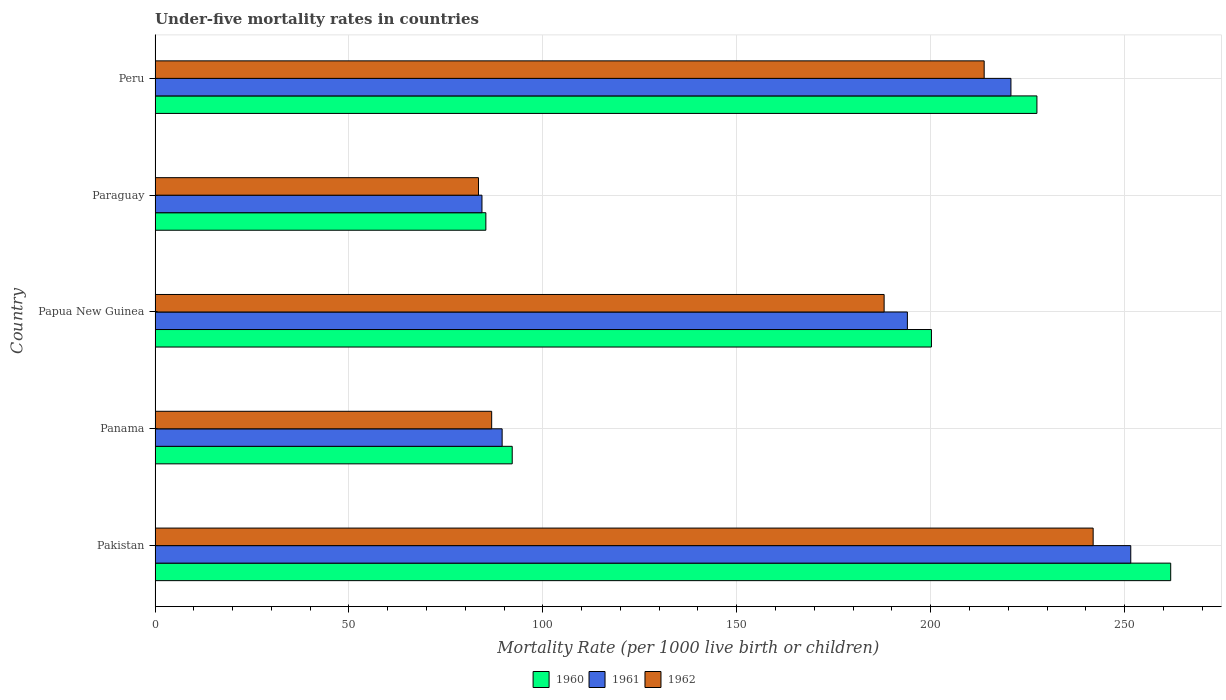How many different coloured bars are there?
Your response must be concise. 3. What is the label of the 3rd group of bars from the top?
Offer a very short reply. Papua New Guinea. What is the under-five mortality rate in 1960 in Paraguay?
Your answer should be compact. 85.3. Across all countries, what is the maximum under-five mortality rate in 1960?
Your answer should be very brief. 261.9. Across all countries, what is the minimum under-five mortality rate in 1962?
Ensure brevity in your answer.  83.4. In which country was the under-five mortality rate in 1961 maximum?
Give a very brief answer. Pakistan. In which country was the under-five mortality rate in 1961 minimum?
Make the answer very short. Paraguay. What is the total under-five mortality rate in 1962 in the graph?
Provide a short and direct response. 813.9. What is the difference between the under-five mortality rate in 1961 in Pakistan and that in Paraguay?
Offer a very short reply. 167.3. What is the difference between the under-five mortality rate in 1960 in Panama and the under-five mortality rate in 1961 in Pakistan?
Your response must be concise. -159.5. What is the average under-five mortality rate in 1960 per country?
Your answer should be very brief. 173.38. What is the difference between the under-five mortality rate in 1962 and under-five mortality rate in 1960 in Papua New Guinea?
Give a very brief answer. -12.2. What is the ratio of the under-five mortality rate in 1961 in Papua New Guinea to that in Paraguay?
Your answer should be compact. 2.3. Is the under-five mortality rate in 1960 in Pakistan less than that in Peru?
Provide a succinct answer. No. What is the difference between the highest and the second highest under-five mortality rate in 1962?
Give a very brief answer. 28.1. What is the difference between the highest and the lowest under-five mortality rate in 1960?
Your response must be concise. 176.6. Are all the bars in the graph horizontal?
Provide a succinct answer. Yes. Does the graph contain any zero values?
Offer a terse response. No. Does the graph contain grids?
Offer a very short reply. Yes. How many legend labels are there?
Offer a terse response. 3. What is the title of the graph?
Make the answer very short. Under-five mortality rates in countries. Does "1968" appear as one of the legend labels in the graph?
Offer a very short reply. No. What is the label or title of the X-axis?
Offer a very short reply. Mortality Rate (per 1000 live birth or children). What is the Mortality Rate (per 1000 live birth or children) of 1960 in Pakistan?
Your answer should be very brief. 261.9. What is the Mortality Rate (per 1000 live birth or children) in 1961 in Pakistan?
Your response must be concise. 251.6. What is the Mortality Rate (per 1000 live birth or children) of 1962 in Pakistan?
Your response must be concise. 241.9. What is the Mortality Rate (per 1000 live birth or children) in 1960 in Panama?
Offer a terse response. 92.1. What is the Mortality Rate (per 1000 live birth or children) of 1961 in Panama?
Provide a succinct answer. 89.5. What is the Mortality Rate (per 1000 live birth or children) in 1962 in Panama?
Offer a terse response. 86.8. What is the Mortality Rate (per 1000 live birth or children) of 1960 in Papua New Guinea?
Provide a succinct answer. 200.2. What is the Mortality Rate (per 1000 live birth or children) in 1961 in Papua New Guinea?
Give a very brief answer. 194. What is the Mortality Rate (per 1000 live birth or children) of 1962 in Papua New Guinea?
Your answer should be compact. 188. What is the Mortality Rate (per 1000 live birth or children) in 1960 in Paraguay?
Make the answer very short. 85.3. What is the Mortality Rate (per 1000 live birth or children) of 1961 in Paraguay?
Ensure brevity in your answer.  84.3. What is the Mortality Rate (per 1000 live birth or children) of 1962 in Paraguay?
Offer a terse response. 83.4. What is the Mortality Rate (per 1000 live birth or children) of 1960 in Peru?
Your response must be concise. 227.4. What is the Mortality Rate (per 1000 live birth or children) in 1961 in Peru?
Offer a very short reply. 220.7. What is the Mortality Rate (per 1000 live birth or children) in 1962 in Peru?
Your response must be concise. 213.8. Across all countries, what is the maximum Mortality Rate (per 1000 live birth or children) of 1960?
Your answer should be compact. 261.9. Across all countries, what is the maximum Mortality Rate (per 1000 live birth or children) in 1961?
Provide a short and direct response. 251.6. Across all countries, what is the maximum Mortality Rate (per 1000 live birth or children) in 1962?
Provide a succinct answer. 241.9. Across all countries, what is the minimum Mortality Rate (per 1000 live birth or children) in 1960?
Give a very brief answer. 85.3. Across all countries, what is the minimum Mortality Rate (per 1000 live birth or children) of 1961?
Ensure brevity in your answer.  84.3. Across all countries, what is the minimum Mortality Rate (per 1000 live birth or children) in 1962?
Your response must be concise. 83.4. What is the total Mortality Rate (per 1000 live birth or children) in 1960 in the graph?
Offer a very short reply. 866.9. What is the total Mortality Rate (per 1000 live birth or children) of 1961 in the graph?
Keep it short and to the point. 840.1. What is the total Mortality Rate (per 1000 live birth or children) in 1962 in the graph?
Offer a very short reply. 813.9. What is the difference between the Mortality Rate (per 1000 live birth or children) in 1960 in Pakistan and that in Panama?
Provide a short and direct response. 169.8. What is the difference between the Mortality Rate (per 1000 live birth or children) in 1961 in Pakistan and that in Panama?
Offer a very short reply. 162.1. What is the difference between the Mortality Rate (per 1000 live birth or children) of 1962 in Pakistan and that in Panama?
Make the answer very short. 155.1. What is the difference between the Mortality Rate (per 1000 live birth or children) in 1960 in Pakistan and that in Papua New Guinea?
Offer a very short reply. 61.7. What is the difference between the Mortality Rate (per 1000 live birth or children) of 1961 in Pakistan and that in Papua New Guinea?
Ensure brevity in your answer.  57.6. What is the difference between the Mortality Rate (per 1000 live birth or children) of 1962 in Pakistan and that in Papua New Guinea?
Provide a short and direct response. 53.9. What is the difference between the Mortality Rate (per 1000 live birth or children) of 1960 in Pakistan and that in Paraguay?
Make the answer very short. 176.6. What is the difference between the Mortality Rate (per 1000 live birth or children) of 1961 in Pakistan and that in Paraguay?
Provide a succinct answer. 167.3. What is the difference between the Mortality Rate (per 1000 live birth or children) of 1962 in Pakistan and that in Paraguay?
Your answer should be compact. 158.5. What is the difference between the Mortality Rate (per 1000 live birth or children) in 1960 in Pakistan and that in Peru?
Your answer should be compact. 34.5. What is the difference between the Mortality Rate (per 1000 live birth or children) in 1961 in Pakistan and that in Peru?
Make the answer very short. 30.9. What is the difference between the Mortality Rate (per 1000 live birth or children) of 1962 in Pakistan and that in Peru?
Provide a succinct answer. 28.1. What is the difference between the Mortality Rate (per 1000 live birth or children) in 1960 in Panama and that in Papua New Guinea?
Provide a short and direct response. -108.1. What is the difference between the Mortality Rate (per 1000 live birth or children) in 1961 in Panama and that in Papua New Guinea?
Give a very brief answer. -104.5. What is the difference between the Mortality Rate (per 1000 live birth or children) of 1962 in Panama and that in Papua New Guinea?
Keep it short and to the point. -101.2. What is the difference between the Mortality Rate (per 1000 live birth or children) of 1961 in Panama and that in Paraguay?
Your answer should be very brief. 5.2. What is the difference between the Mortality Rate (per 1000 live birth or children) of 1962 in Panama and that in Paraguay?
Your response must be concise. 3.4. What is the difference between the Mortality Rate (per 1000 live birth or children) of 1960 in Panama and that in Peru?
Keep it short and to the point. -135.3. What is the difference between the Mortality Rate (per 1000 live birth or children) of 1961 in Panama and that in Peru?
Offer a very short reply. -131.2. What is the difference between the Mortality Rate (per 1000 live birth or children) in 1962 in Panama and that in Peru?
Ensure brevity in your answer.  -127. What is the difference between the Mortality Rate (per 1000 live birth or children) in 1960 in Papua New Guinea and that in Paraguay?
Ensure brevity in your answer.  114.9. What is the difference between the Mortality Rate (per 1000 live birth or children) of 1961 in Papua New Guinea and that in Paraguay?
Make the answer very short. 109.7. What is the difference between the Mortality Rate (per 1000 live birth or children) in 1962 in Papua New Guinea and that in Paraguay?
Offer a very short reply. 104.6. What is the difference between the Mortality Rate (per 1000 live birth or children) of 1960 in Papua New Guinea and that in Peru?
Ensure brevity in your answer.  -27.2. What is the difference between the Mortality Rate (per 1000 live birth or children) of 1961 in Papua New Guinea and that in Peru?
Your answer should be very brief. -26.7. What is the difference between the Mortality Rate (per 1000 live birth or children) in 1962 in Papua New Guinea and that in Peru?
Offer a terse response. -25.8. What is the difference between the Mortality Rate (per 1000 live birth or children) in 1960 in Paraguay and that in Peru?
Your answer should be compact. -142.1. What is the difference between the Mortality Rate (per 1000 live birth or children) in 1961 in Paraguay and that in Peru?
Your answer should be compact. -136.4. What is the difference between the Mortality Rate (per 1000 live birth or children) of 1962 in Paraguay and that in Peru?
Keep it short and to the point. -130.4. What is the difference between the Mortality Rate (per 1000 live birth or children) of 1960 in Pakistan and the Mortality Rate (per 1000 live birth or children) of 1961 in Panama?
Offer a very short reply. 172.4. What is the difference between the Mortality Rate (per 1000 live birth or children) of 1960 in Pakistan and the Mortality Rate (per 1000 live birth or children) of 1962 in Panama?
Provide a succinct answer. 175.1. What is the difference between the Mortality Rate (per 1000 live birth or children) in 1961 in Pakistan and the Mortality Rate (per 1000 live birth or children) in 1962 in Panama?
Offer a very short reply. 164.8. What is the difference between the Mortality Rate (per 1000 live birth or children) in 1960 in Pakistan and the Mortality Rate (per 1000 live birth or children) in 1961 in Papua New Guinea?
Provide a succinct answer. 67.9. What is the difference between the Mortality Rate (per 1000 live birth or children) in 1960 in Pakistan and the Mortality Rate (per 1000 live birth or children) in 1962 in Papua New Guinea?
Provide a succinct answer. 73.9. What is the difference between the Mortality Rate (per 1000 live birth or children) of 1961 in Pakistan and the Mortality Rate (per 1000 live birth or children) of 1962 in Papua New Guinea?
Your answer should be very brief. 63.6. What is the difference between the Mortality Rate (per 1000 live birth or children) in 1960 in Pakistan and the Mortality Rate (per 1000 live birth or children) in 1961 in Paraguay?
Ensure brevity in your answer.  177.6. What is the difference between the Mortality Rate (per 1000 live birth or children) in 1960 in Pakistan and the Mortality Rate (per 1000 live birth or children) in 1962 in Paraguay?
Give a very brief answer. 178.5. What is the difference between the Mortality Rate (per 1000 live birth or children) in 1961 in Pakistan and the Mortality Rate (per 1000 live birth or children) in 1962 in Paraguay?
Give a very brief answer. 168.2. What is the difference between the Mortality Rate (per 1000 live birth or children) of 1960 in Pakistan and the Mortality Rate (per 1000 live birth or children) of 1961 in Peru?
Provide a succinct answer. 41.2. What is the difference between the Mortality Rate (per 1000 live birth or children) of 1960 in Pakistan and the Mortality Rate (per 1000 live birth or children) of 1962 in Peru?
Your response must be concise. 48.1. What is the difference between the Mortality Rate (per 1000 live birth or children) in 1961 in Pakistan and the Mortality Rate (per 1000 live birth or children) in 1962 in Peru?
Your answer should be very brief. 37.8. What is the difference between the Mortality Rate (per 1000 live birth or children) of 1960 in Panama and the Mortality Rate (per 1000 live birth or children) of 1961 in Papua New Guinea?
Give a very brief answer. -101.9. What is the difference between the Mortality Rate (per 1000 live birth or children) in 1960 in Panama and the Mortality Rate (per 1000 live birth or children) in 1962 in Papua New Guinea?
Your answer should be very brief. -95.9. What is the difference between the Mortality Rate (per 1000 live birth or children) of 1961 in Panama and the Mortality Rate (per 1000 live birth or children) of 1962 in Papua New Guinea?
Your answer should be very brief. -98.5. What is the difference between the Mortality Rate (per 1000 live birth or children) of 1960 in Panama and the Mortality Rate (per 1000 live birth or children) of 1961 in Paraguay?
Your response must be concise. 7.8. What is the difference between the Mortality Rate (per 1000 live birth or children) of 1960 in Panama and the Mortality Rate (per 1000 live birth or children) of 1961 in Peru?
Provide a succinct answer. -128.6. What is the difference between the Mortality Rate (per 1000 live birth or children) in 1960 in Panama and the Mortality Rate (per 1000 live birth or children) in 1962 in Peru?
Offer a terse response. -121.7. What is the difference between the Mortality Rate (per 1000 live birth or children) in 1961 in Panama and the Mortality Rate (per 1000 live birth or children) in 1962 in Peru?
Keep it short and to the point. -124.3. What is the difference between the Mortality Rate (per 1000 live birth or children) in 1960 in Papua New Guinea and the Mortality Rate (per 1000 live birth or children) in 1961 in Paraguay?
Make the answer very short. 115.9. What is the difference between the Mortality Rate (per 1000 live birth or children) in 1960 in Papua New Guinea and the Mortality Rate (per 1000 live birth or children) in 1962 in Paraguay?
Ensure brevity in your answer.  116.8. What is the difference between the Mortality Rate (per 1000 live birth or children) of 1961 in Papua New Guinea and the Mortality Rate (per 1000 live birth or children) of 1962 in Paraguay?
Your answer should be compact. 110.6. What is the difference between the Mortality Rate (per 1000 live birth or children) in 1960 in Papua New Guinea and the Mortality Rate (per 1000 live birth or children) in 1961 in Peru?
Your response must be concise. -20.5. What is the difference between the Mortality Rate (per 1000 live birth or children) of 1960 in Papua New Guinea and the Mortality Rate (per 1000 live birth or children) of 1962 in Peru?
Keep it short and to the point. -13.6. What is the difference between the Mortality Rate (per 1000 live birth or children) in 1961 in Papua New Guinea and the Mortality Rate (per 1000 live birth or children) in 1962 in Peru?
Offer a very short reply. -19.8. What is the difference between the Mortality Rate (per 1000 live birth or children) in 1960 in Paraguay and the Mortality Rate (per 1000 live birth or children) in 1961 in Peru?
Make the answer very short. -135.4. What is the difference between the Mortality Rate (per 1000 live birth or children) of 1960 in Paraguay and the Mortality Rate (per 1000 live birth or children) of 1962 in Peru?
Give a very brief answer. -128.5. What is the difference between the Mortality Rate (per 1000 live birth or children) in 1961 in Paraguay and the Mortality Rate (per 1000 live birth or children) in 1962 in Peru?
Provide a succinct answer. -129.5. What is the average Mortality Rate (per 1000 live birth or children) of 1960 per country?
Ensure brevity in your answer.  173.38. What is the average Mortality Rate (per 1000 live birth or children) in 1961 per country?
Your answer should be very brief. 168.02. What is the average Mortality Rate (per 1000 live birth or children) in 1962 per country?
Your response must be concise. 162.78. What is the difference between the Mortality Rate (per 1000 live birth or children) in 1960 and Mortality Rate (per 1000 live birth or children) in 1961 in Pakistan?
Ensure brevity in your answer.  10.3. What is the difference between the Mortality Rate (per 1000 live birth or children) in 1960 and Mortality Rate (per 1000 live birth or children) in 1962 in Pakistan?
Offer a very short reply. 20. What is the difference between the Mortality Rate (per 1000 live birth or children) of 1960 and Mortality Rate (per 1000 live birth or children) of 1961 in Papua New Guinea?
Offer a terse response. 6.2. What is the difference between the Mortality Rate (per 1000 live birth or children) in 1960 and Mortality Rate (per 1000 live birth or children) in 1962 in Papua New Guinea?
Your answer should be compact. 12.2. What is the difference between the Mortality Rate (per 1000 live birth or children) in 1961 and Mortality Rate (per 1000 live birth or children) in 1962 in Papua New Guinea?
Offer a very short reply. 6. What is the difference between the Mortality Rate (per 1000 live birth or children) of 1960 and Mortality Rate (per 1000 live birth or children) of 1962 in Paraguay?
Your answer should be compact. 1.9. What is the ratio of the Mortality Rate (per 1000 live birth or children) of 1960 in Pakistan to that in Panama?
Offer a very short reply. 2.84. What is the ratio of the Mortality Rate (per 1000 live birth or children) of 1961 in Pakistan to that in Panama?
Offer a terse response. 2.81. What is the ratio of the Mortality Rate (per 1000 live birth or children) in 1962 in Pakistan to that in Panama?
Your answer should be compact. 2.79. What is the ratio of the Mortality Rate (per 1000 live birth or children) in 1960 in Pakistan to that in Papua New Guinea?
Provide a short and direct response. 1.31. What is the ratio of the Mortality Rate (per 1000 live birth or children) in 1961 in Pakistan to that in Papua New Guinea?
Your answer should be compact. 1.3. What is the ratio of the Mortality Rate (per 1000 live birth or children) of 1962 in Pakistan to that in Papua New Guinea?
Offer a terse response. 1.29. What is the ratio of the Mortality Rate (per 1000 live birth or children) in 1960 in Pakistan to that in Paraguay?
Your response must be concise. 3.07. What is the ratio of the Mortality Rate (per 1000 live birth or children) in 1961 in Pakistan to that in Paraguay?
Ensure brevity in your answer.  2.98. What is the ratio of the Mortality Rate (per 1000 live birth or children) in 1962 in Pakistan to that in Paraguay?
Offer a terse response. 2.9. What is the ratio of the Mortality Rate (per 1000 live birth or children) in 1960 in Pakistan to that in Peru?
Keep it short and to the point. 1.15. What is the ratio of the Mortality Rate (per 1000 live birth or children) of 1961 in Pakistan to that in Peru?
Keep it short and to the point. 1.14. What is the ratio of the Mortality Rate (per 1000 live birth or children) in 1962 in Pakistan to that in Peru?
Your response must be concise. 1.13. What is the ratio of the Mortality Rate (per 1000 live birth or children) of 1960 in Panama to that in Papua New Guinea?
Your response must be concise. 0.46. What is the ratio of the Mortality Rate (per 1000 live birth or children) of 1961 in Panama to that in Papua New Guinea?
Make the answer very short. 0.46. What is the ratio of the Mortality Rate (per 1000 live birth or children) in 1962 in Panama to that in Papua New Guinea?
Your response must be concise. 0.46. What is the ratio of the Mortality Rate (per 1000 live birth or children) of 1960 in Panama to that in Paraguay?
Provide a short and direct response. 1.08. What is the ratio of the Mortality Rate (per 1000 live birth or children) in 1961 in Panama to that in Paraguay?
Your response must be concise. 1.06. What is the ratio of the Mortality Rate (per 1000 live birth or children) in 1962 in Panama to that in Paraguay?
Your answer should be compact. 1.04. What is the ratio of the Mortality Rate (per 1000 live birth or children) in 1960 in Panama to that in Peru?
Your response must be concise. 0.41. What is the ratio of the Mortality Rate (per 1000 live birth or children) of 1961 in Panama to that in Peru?
Keep it short and to the point. 0.41. What is the ratio of the Mortality Rate (per 1000 live birth or children) of 1962 in Panama to that in Peru?
Keep it short and to the point. 0.41. What is the ratio of the Mortality Rate (per 1000 live birth or children) in 1960 in Papua New Guinea to that in Paraguay?
Give a very brief answer. 2.35. What is the ratio of the Mortality Rate (per 1000 live birth or children) in 1961 in Papua New Guinea to that in Paraguay?
Ensure brevity in your answer.  2.3. What is the ratio of the Mortality Rate (per 1000 live birth or children) of 1962 in Papua New Guinea to that in Paraguay?
Your answer should be very brief. 2.25. What is the ratio of the Mortality Rate (per 1000 live birth or children) in 1960 in Papua New Guinea to that in Peru?
Keep it short and to the point. 0.88. What is the ratio of the Mortality Rate (per 1000 live birth or children) of 1961 in Papua New Guinea to that in Peru?
Offer a terse response. 0.88. What is the ratio of the Mortality Rate (per 1000 live birth or children) in 1962 in Papua New Guinea to that in Peru?
Make the answer very short. 0.88. What is the ratio of the Mortality Rate (per 1000 live birth or children) of 1960 in Paraguay to that in Peru?
Ensure brevity in your answer.  0.38. What is the ratio of the Mortality Rate (per 1000 live birth or children) in 1961 in Paraguay to that in Peru?
Your response must be concise. 0.38. What is the ratio of the Mortality Rate (per 1000 live birth or children) of 1962 in Paraguay to that in Peru?
Offer a very short reply. 0.39. What is the difference between the highest and the second highest Mortality Rate (per 1000 live birth or children) of 1960?
Offer a very short reply. 34.5. What is the difference between the highest and the second highest Mortality Rate (per 1000 live birth or children) in 1961?
Provide a succinct answer. 30.9. What is the difference between the highest and the second highest Mortality Rate (per 1000 live birth or children) in 1962?
Provide a short and direct response. 28.1. What is the difference between the highest and the lowest Mortality Rate (per 1000 live birth or children) in 1960?
Provide a short and direct response. 176.6. What is the difference between the highest and the lowest Mortality Rate (per 1000 live birth or children) of 1961?
Provide a succinct answer. 167.3. What is the difference between the highest and the lowest Mortality Rate (per 1000 live birth or children) in 1962?
Ensure brevity in your answer.  158.5. 